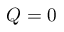<formula> <loc_0><loc_0><loc_500><loc_500>Q = 0</formula> 